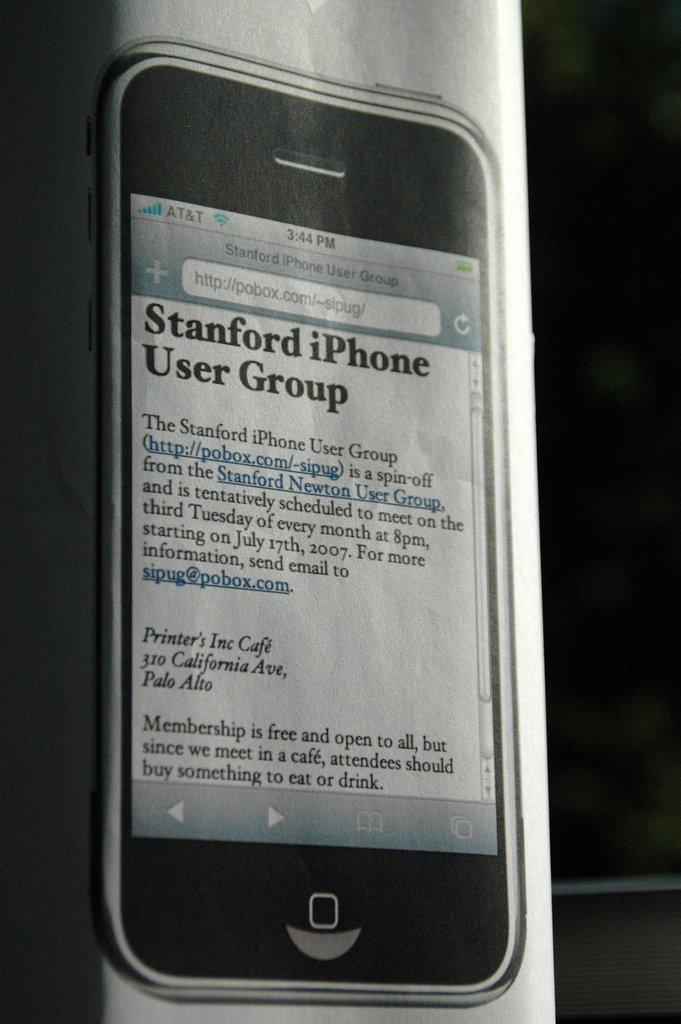<image>
Share a concise interpretation of the image provided. The article shown is from stanford iPhone user group. 